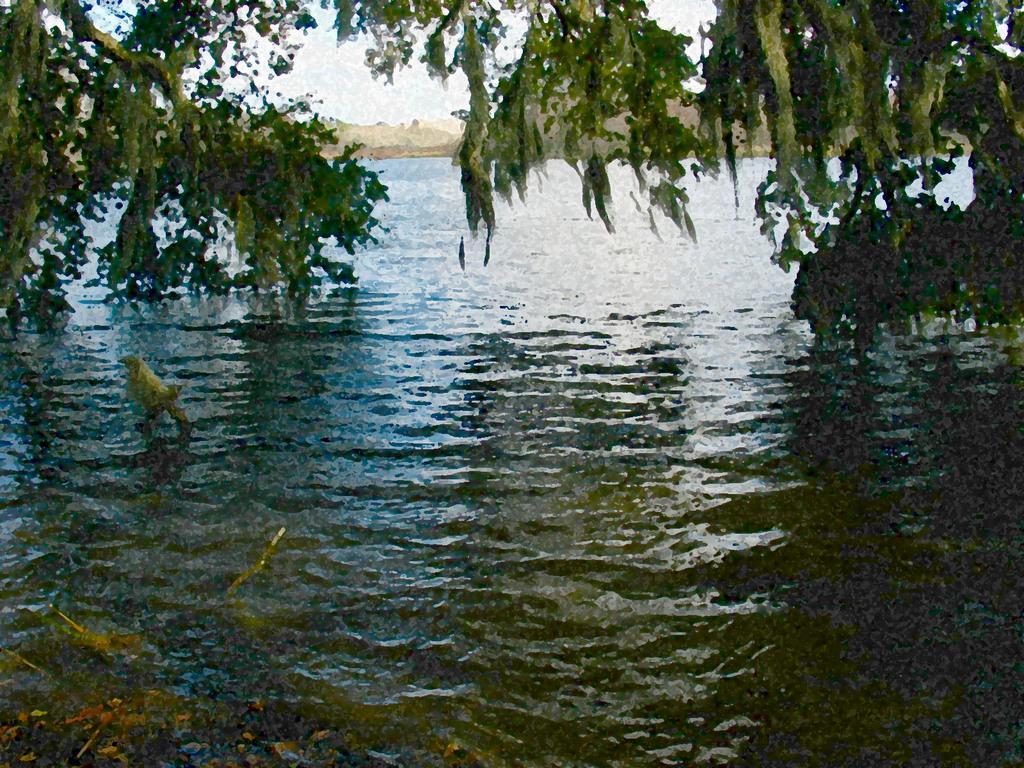In one or two sentences, can you explain what this image depicts? In this image, we can see a bird on the water and in the background, there are trees. 